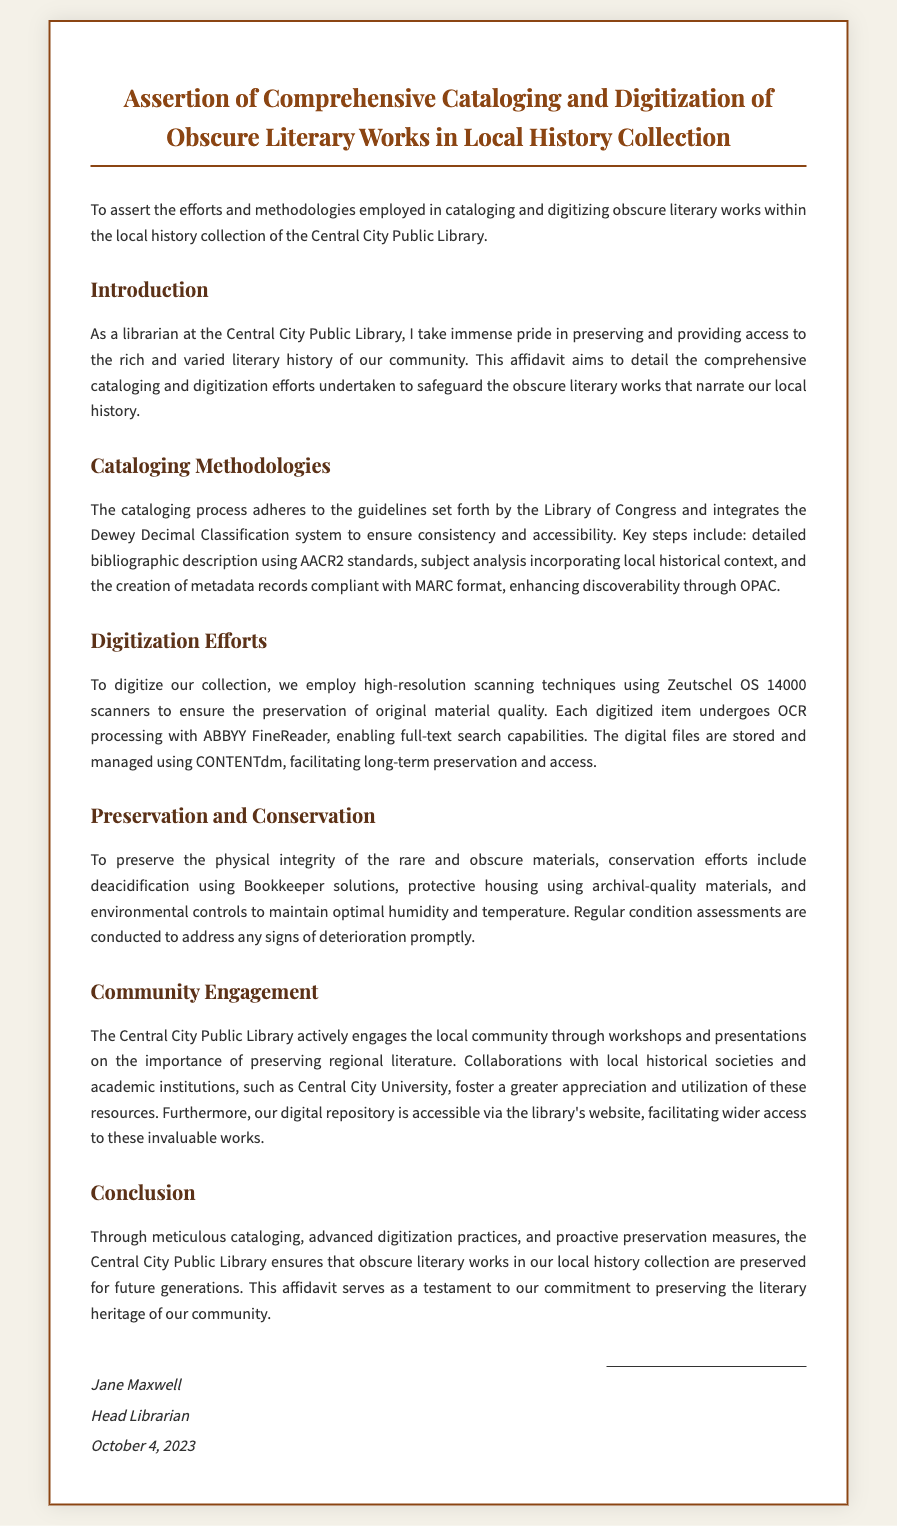What is the title of the affidavit? The title is stated clearly at the beginning of the document, emphasizing the focus on cataloging and digitization efforts.
Answer: Assertion of Comprehensive Cataloging and Digitization of Obscure Literary Works in Local History Collection Who is the affiant? The document names the individual asserting the affidavit, including their role and title.
Answer: Jane Maxwell What date was the affidavit signed? The signing date is mentioned in the signature section of the document.
Answer: October 4, 2023 What scanning technique is used for digitization? The specific scanning technique is highlighted in the digitization efforts section of the document.
Answer: Zeutschel OS 14000 scanners What software is used for OCR processing? The document specifies the application utilized for optical character recognition processing during digitization.
Answer: ABBYY FineReader What classification system is used for cataloging? The document outlines the classification system adopted for organizing the literary works.
Answer: Dewey Decimal Classification Which library standards are followed for bibliographic description? The affidavit mentions the standards adhered to for ensuring proper bibliographic descriptions.
Answer: AACR2 standards Who collaborates with the library for community engagement? The document indicates local institutions that collaborate with the library in engaging the community.
Answer: Central City University What is the purpose of regular condition assessments? The document provides a reason for conducting periodic evaluations of the collection's physical condition.
Answer: Address any signs of deterioration promptly 